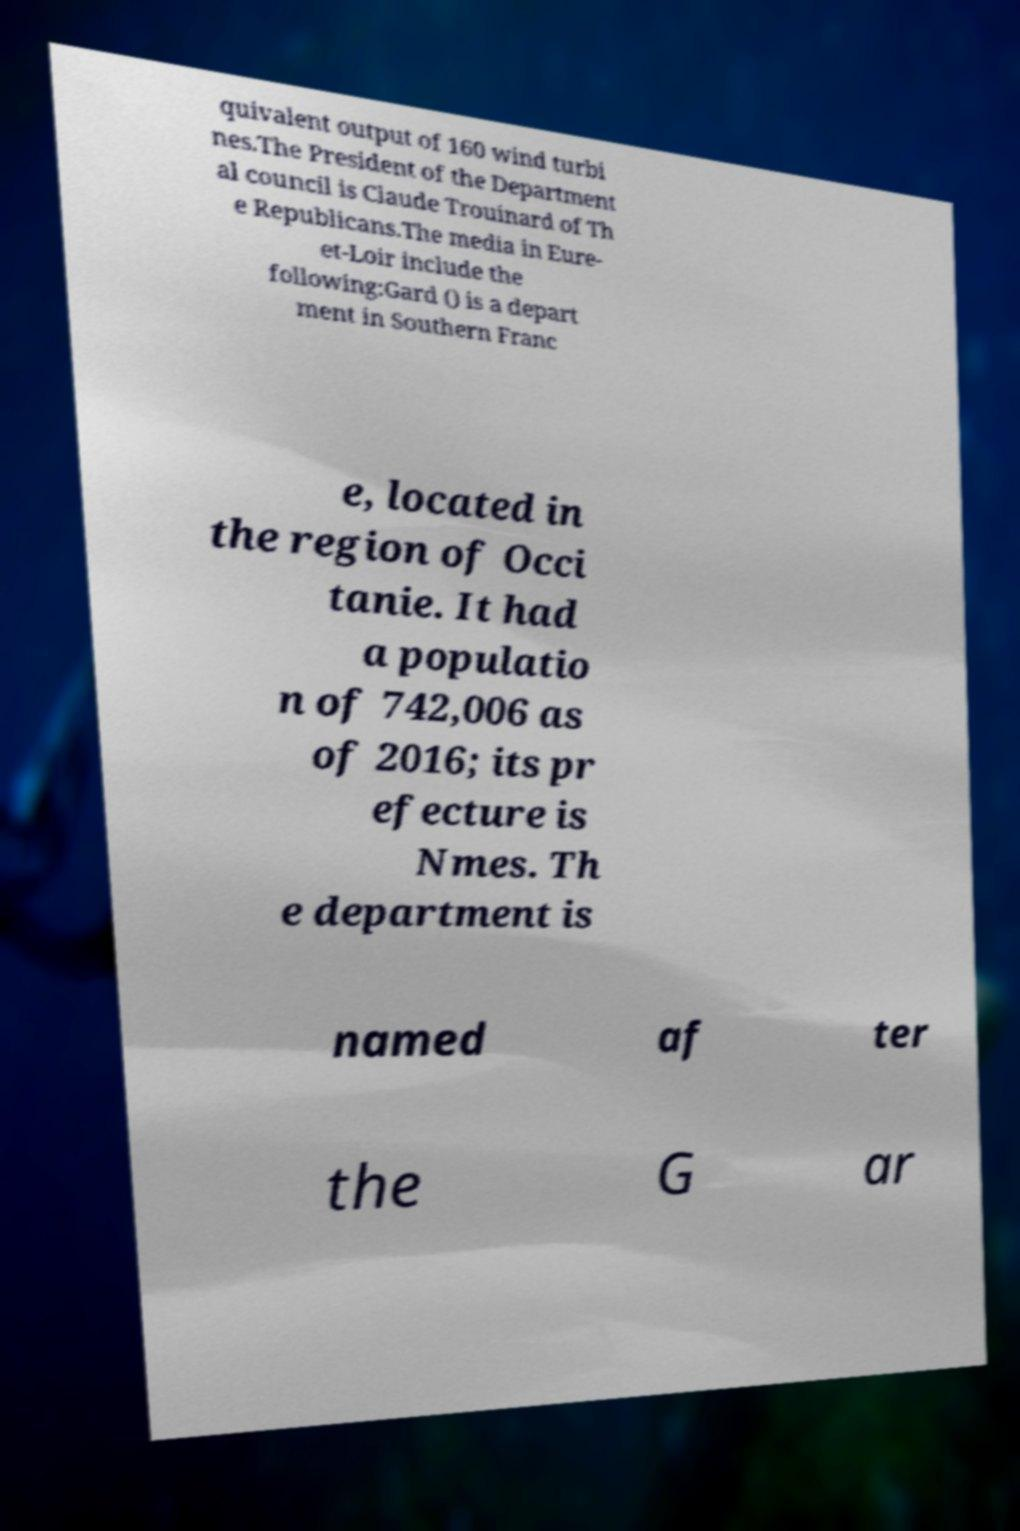Please identify and transcribe the text found in this image. quivalent output of 160 wind turbi nes.The President of the Department al council is Claude Trouinard of Th e Republicans.The media in Eure- et-Loir include the following:Gard () is a depart ment in Southern Franc e, located in the region of Occi tanie. It had a populatio n of 742,006 as of 2016; its pr efecture is Nmes. Th e department is named af ter the G ar 